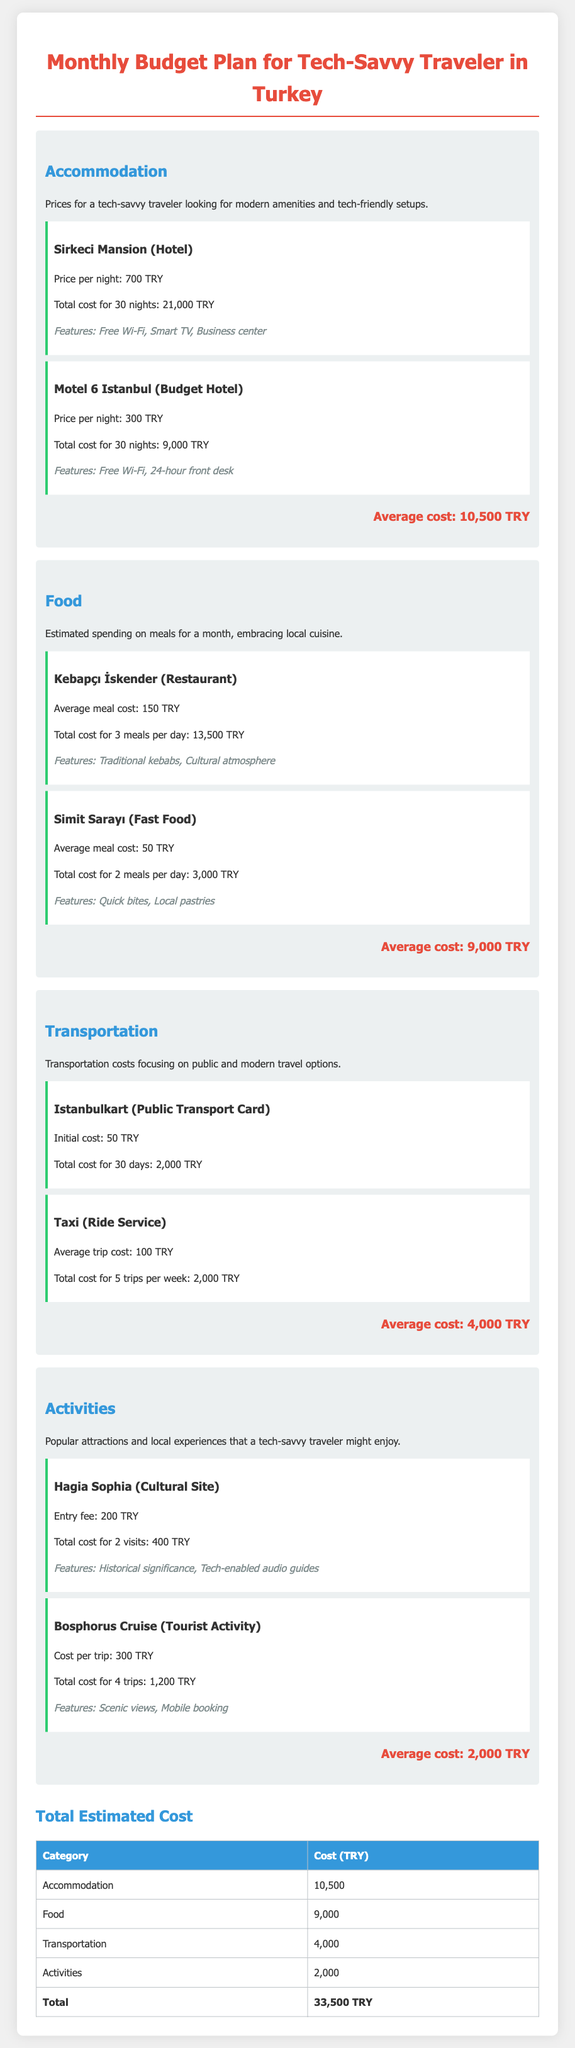What is the price per night for Sirkeci Mansion? The price per night for Sirkeci Mansion is mentioned in the accommodation section.
Answer: 700 TRY What is the total cost for food at Kebapçı İskender for a month? The total cost for meals at Kebapçı İskender for 3 meals per day is calculated in the food section.
Answer: 13,500 TRY How much is the cost for transportation using the Istanbulkart? The transportation section indicates the total cost for using the Istanbulkart over 30 days.
Answer: 2,000 TRY What are the features of the Bosphorus Cruise activity? The features of the Bosphorus Cruise are listed in the activities section.
Answer: Scenic views, Mobile booking What is the average cost of accommodation? The average cost is summarized at the end of the accommodation section.
Answer: 10,500 TRY What is the total estimated cost for the month? The total estimated cost is calculated by summing all costs in the table at the end of the document.
Answer: 33,500 TRY How many visits to Hagia Sophia are considered in the cost? The number of visits to Hagia Sophia for calculating the total cost is specified in the activities section.
Answer: 2 visits What is the total cost for transportation from taxi rides? The total cost for taxi rides is outlined in the transportation section of the budget.
Answer: 2,000 TRY What type of traveler is this budget plan targeted towards? The document indicates the type of traveler this budget plan is designed for in the title.
Answer: Tech-savvy traveler 